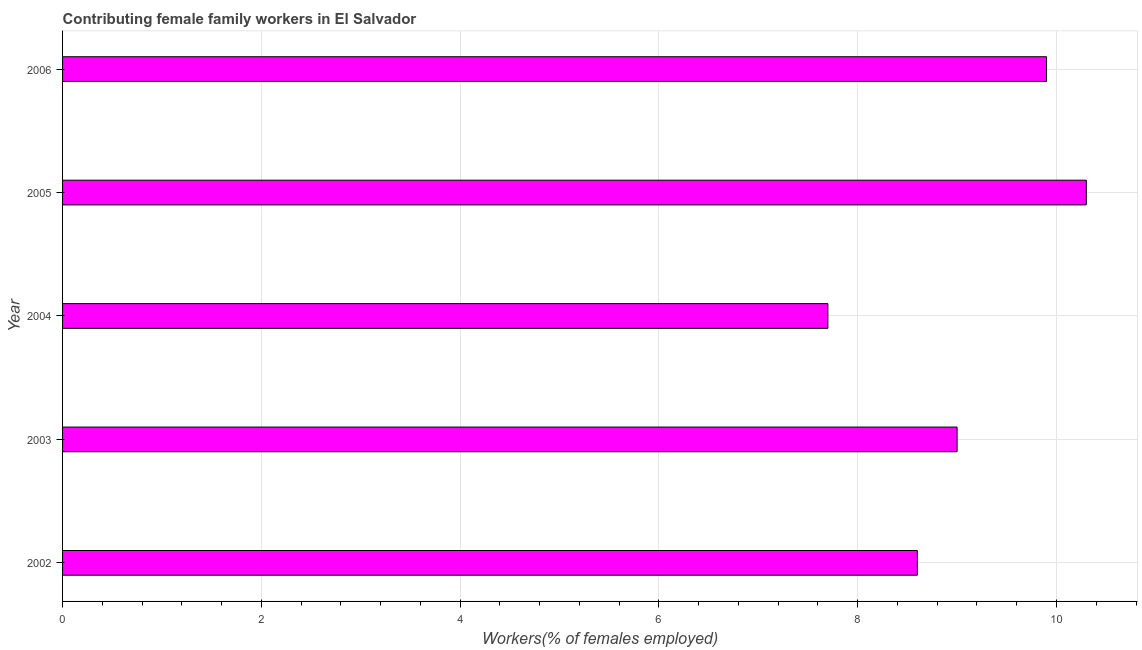What is the title of the graph?
Give a very brief answer. Contributing female family workers in El Salvador. What is the label or title of the X-axis?
Your answer should be very brief. Workers(% of females employed). What is the contributing female family workers in 2005?
Give a very brief answer. 10.3. Across all years, what is the maximum contributing female family workers?
Your answer should be compact. 10.3. Across all years, what is the minimum contributing female family workers?
Provide a succinct answer. 7.7. In which year was the contributing female family workers maximum?
Provide a succinct answer. 2005. In which year was the contributing female family workers minimum?
Provide a succinct answer. 2004. What is the sum of the contributing female family workers?
Offer a very short reply. 45.5. What is the average contributing female family workers per year?
Make the answer very short. 9.1. What is the median contributing female family workers?
Give a very brief answer. 9. In how many years, is the contributing female family workers greater than 5.6 %?
Your response must be concise. 5. Do a majority of the years between 2002 and 2005 (inclusive) have contributing female family workers greater than 1.6 %?
Make the answer very short. Yes. What is the ratio of the contributing female family workers in 2004 to that in 2006?
Your answer should be very brief. 0.78. Is the contributing female family workers in 2002 less than that in 2004?
Provide a short and direct response. No. Are all the bars in the graph horizontal?
Offer a very short reply. Yes. What is the difference between two consecutive major ticks on the X-axis?
Provide a succinct answer. 2. What is the Workers(% of females employed) in 2002?
Your answer should be compact. 8.6. What is the Workers(% of females employed) in 2003?
Provide a succinct answer. 9. What is the Workers(% of females employed) in 2004?
Ensure brevity in your answer.  7.7. What is the Workers(% of females employed) of 2005?
Provide a short and direct response. 10.3. What is the Workers(% of females employed) in 2006?
Keep it short and to the point. 9.9. What is the difference between the Workers(% of females employed) in 2002 and 2003?
Offer a terse response. -0.4. What is the difference between the Workers(% of females employed) in 2002 and 2005?
Ensure brevity in your answer.  -1.7. What is the difference between the Workers(% of females employed) in 2003 and 2004?
Keep it short and to the point. 1.3. What is the difference between the Workers(% of females employed) in 2003 and 2005?
Provide a short and direct response. -1.3. What is the difference between the Workers(% of females employed) in 2003 and 2006?
Offer a terse response. -0.9. What is the difference between the Workers(% of females employed) in 2004 and 2006?
Offer a terse response. -2.2. What is the difference between the Workers(% of females employed) in 2005 and 2006?
Provide a short and direct response. 0.4. What is the ratio of the Workers(% of females employed) in 2002 to that in 2003?
Keep it short and to the point. 0.96. What is the ratio of the Workers(% of females employed) in 2002 to that in 2004?
Your answer should be very brief. 1.12. What is the ratio of the Workers(% of females employed) in 2002 to that in 2005?
Your answer should be very brief. 0.83. What is the ratio of the Workers(% of females employed) in 2002 to that in 2006?
Make the answer very short. 0.87. What is the ratio of the Workers(% of females employed) in 2003 to that in 2004?
Offer a terse response. 1.17. What is the ratio of the Workers(% of females employed) in 2003 to that in 2005?
Provide a short and direct response. 0.87. What is the ratio of the Workers(% of females employed) in 2003 to that in 2006?
Keep it short and to the point. 0.91. What is the ratio of the Workers(% of females employed) in 2004 to that in 2005?
Keep it short and to the point. 0.75. What is the ratio of the Workers(% of females employed) in 2004 to that in 2006?
Offer a terse response. 0.78. What is the ratio of the Workers(% of females employed) in 2005 to that in 2006?
Provide a short and direct response. 1.04. 